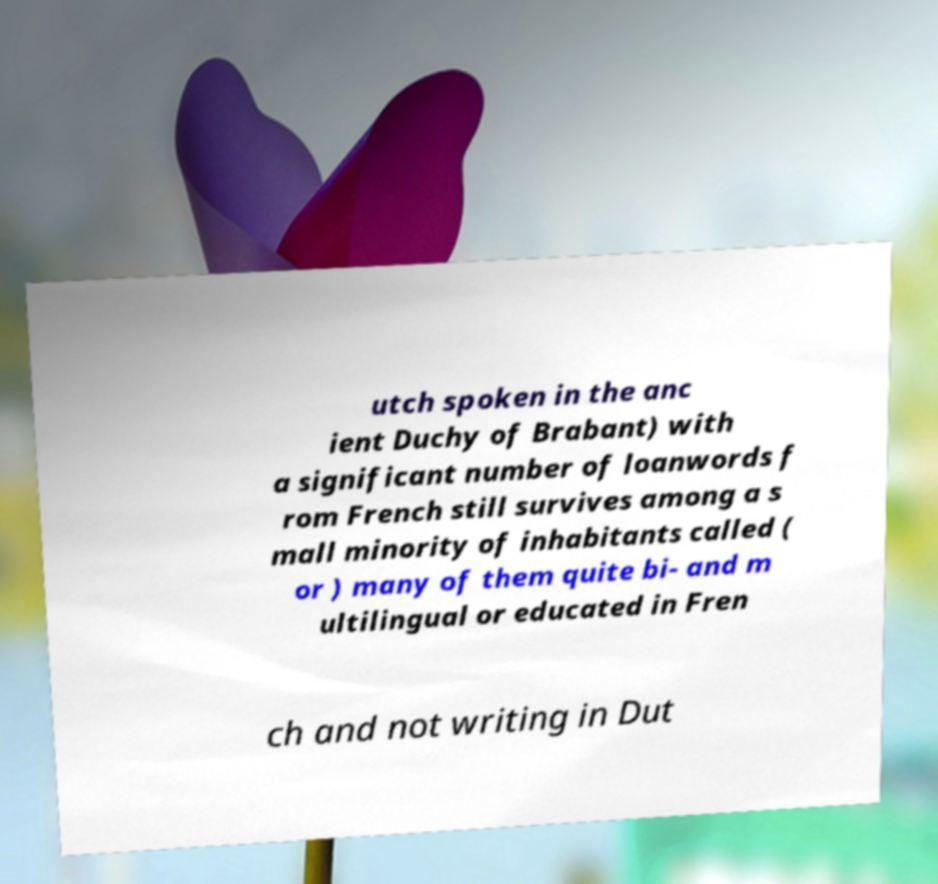Please identify and transcribe the text found in this image. utch spoken in the anc ient Duchy of Brabant) with a significant number of loanwords f rom French still survives among a s mall minority of inhabitants called ( or ) many of them quite bi- and m ultilingual or educated in Fren ch and not writing in Dut 